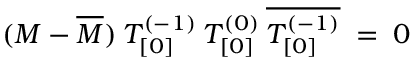<formula> <loc_0><loc_0><loc_500><loc_500>( M - \overline { M } ) \, T _ { [ 0 ] } ^ { ( - 1 ) } \, T _ { [ 0 ] } ^ { ( 0 ) } \, \overline { { { T _ { [ 0 ] } ^ { ( - 1 ) } } } } \, = \, 0</formula> 